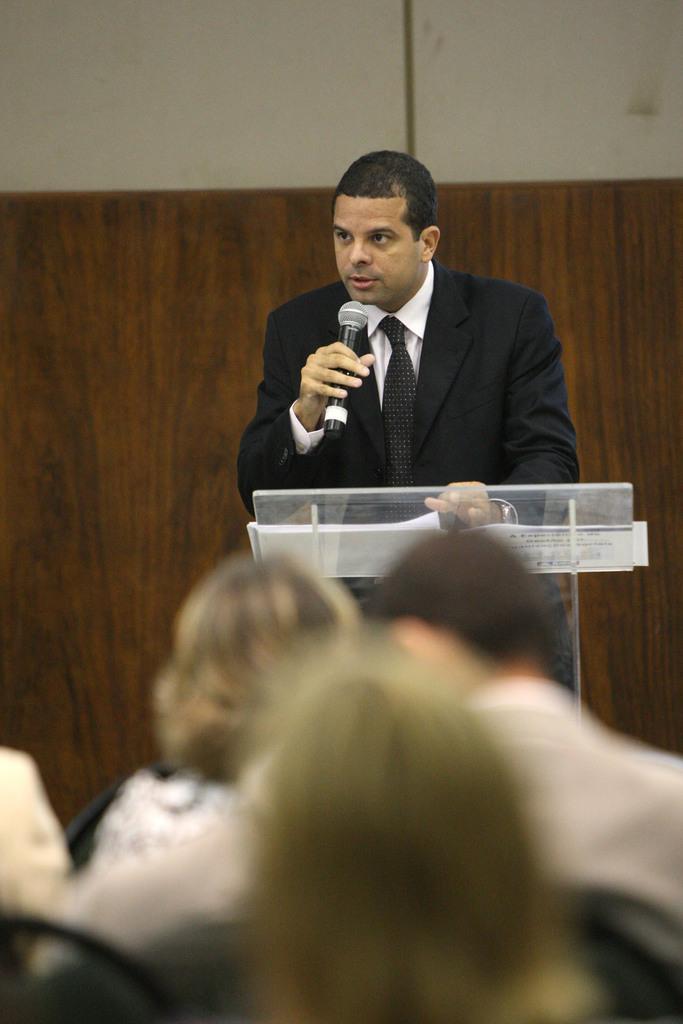How would you summarize this image in a sentence or two? In this image i can see group of people sitting on chair at the back ground i can see a man standing in front of a podium a man holding a micro phone at the back ground i can see a wooden wall. 